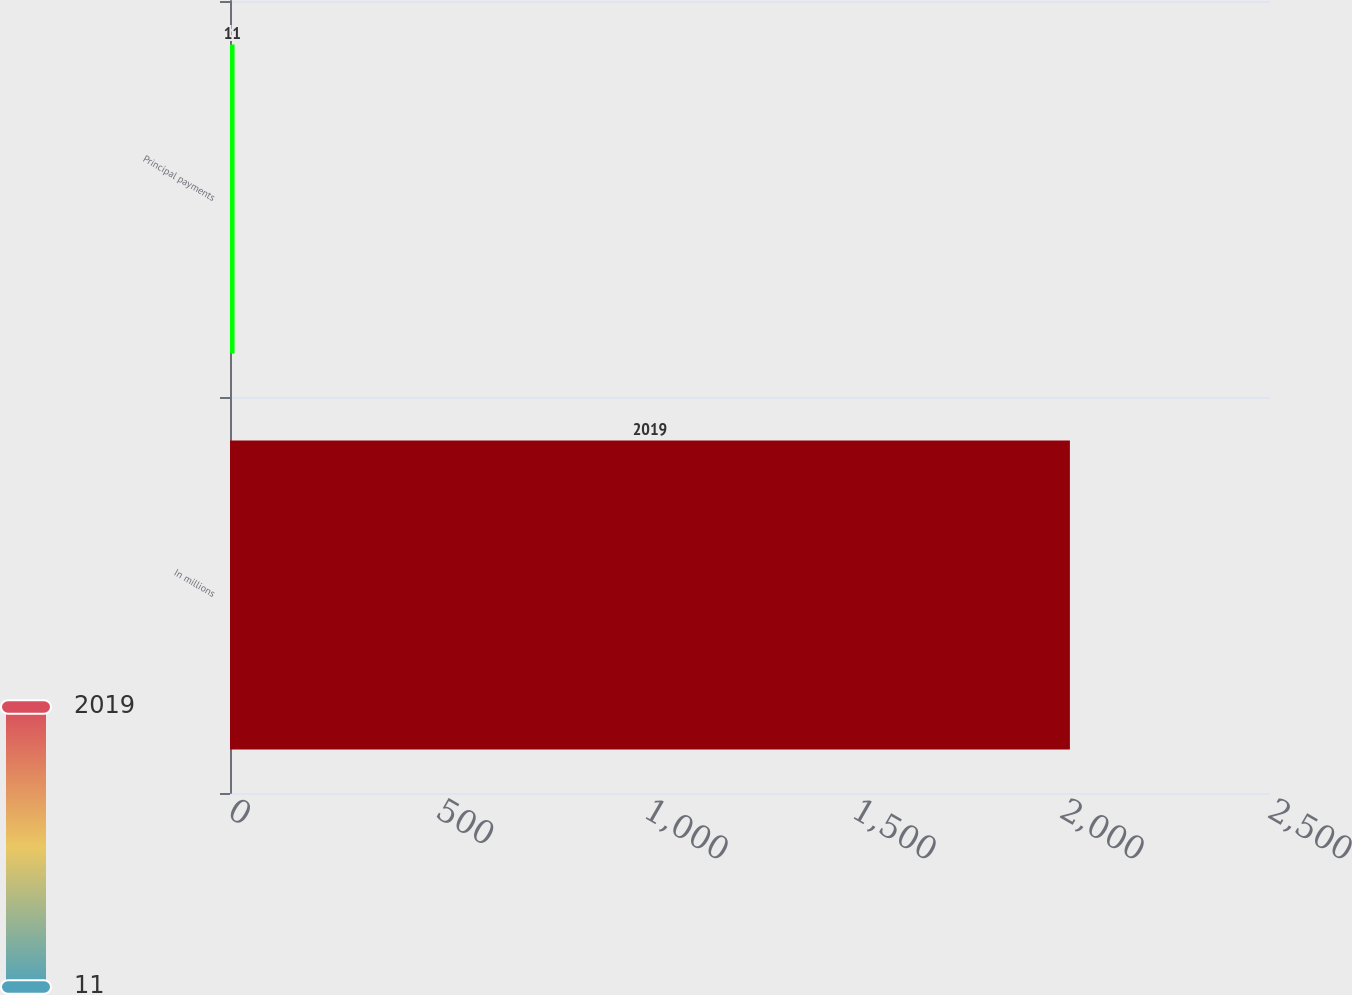Convert chart. <chart><loc_0><loc_0><loc_500><loc_500><bar_chart><fcel>In millions<fcel>Principal payments<nl><fcel>2019<fcel>11<nl></chart> 